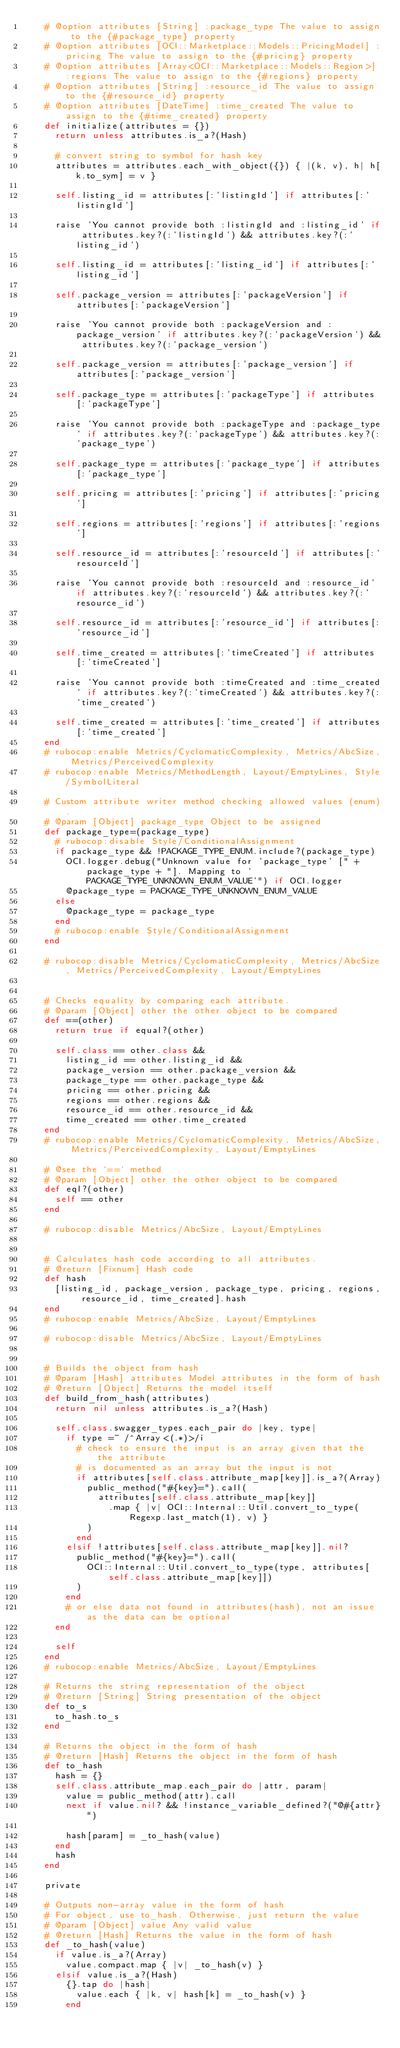Convert code to text. <code><loc_0><loc_0><loc_500><loc_500><_Ruby_>    # @option attributes [String] :package_type The value to assign to the {#package_type} property
    # @option attributes [OCI::Marketplace::Models::PricingModel] :pricing The value to assign to the {#pricing} property
    # @option attributes [Array<OCI::Marketplace::Models::Region>] :regions The value to assign to the {#regions} property
    # @option attributes [String] :resource_id The value to assign to the {#resource_id} property
    # @option attributes [DateTime] :time_created The value to assign to the {#time_created} property
    def initialize(attributes = {})
      return unless attributes.is_a?(Hash)

      # convert string to symbol for hash key
      attributes = attributes.each_with_object({}) { |(k, v), h| h[k.to_sym] = v }

      self.listing_id = attributes[:'listingId'] if attributes[:'listingId']

      raise 'You cannot provide both :listingId and :listing_id' if attributes.key?(:'listingId') && attributes.key?(:'listing_id')

      self.listing_id = attributes[:'listing_id'] if attributes[:'listing_id']

      self.package_version = attributes[:'packageVersion'] if attributes[:'packageVersion']

      raise 'You cannot provide both :packageVersion and :package_version' if attributes.key?(:'packageVersion') && attributes.key?(:'package_version')

      self.package_version = attributes[:'package_version'] if attributes[:'package_version']

      self.package_type = attributes[:'packageType'] if attributes[:'packageType']

      raise 'You cannot provide both :packageType and :package_type' if attributes.key?(:'packageType') && attributes.key?(:'package_type')

      self.package_type = attributes[:'package_type'] if attributes[:'package_type']

      self.pricing = attributes[:'pricing'] if attributes[:'pricing']

      self.regions = attributes[:'regions'] if attributes[:'regions']

      self.resource_id = attributes[:'resourceId'] if attributes[:'resourceId']

      raise 'You cannot provide both :resourceId and :resource_id' if attributes.key?(:'resourceId') && attributes.key?(:'resource_id')

      self.resource_id = attributes[:'resource_id'] if attributes[:'resource_id']

      self.time_created = attributes[:'timeCreated'] if attributes[:'timeCreated']

      raise 'You cannot provide both :timeCreated and :time_created' if attributes.key?(:'timeCreated') && attributes.key?(:'time_created')

      self.time_created = attributes[:'time_created'] if attributes[:'time_created']
    end
    # rubocop:enable Metrics/CyclomaticComplexity, Metrics/AbcSize, Metrics/PerceivedComplexity
    # rubocop:enable Metrics/MethodLength, Layout/EmptyLines, Style/SymbolLiteral

    # Custom attribute writer method checking allowed values (enum).
    # @param [Object] package_type Object to be assigned
    def package_type=(package_type)
      # rubocop:disable Style/ConditionalAssignment
      if package_type && !PACKAGE_TYPE_ENUM.include?(package_type)
        OCI.logger.debug("Unknown value for 'package_type' [" + package_type + "]. Mapping to 'PACKAGE_TYPE_UNKNOWN_ENUM_VALUE'") if OCI.logger
        @package_type = PACKAGE_TYPE_UNKNOWN_ENUM_VALUE
      else
        @package_type = package_type
      end
      # rubocop:enable Style/ConditionalAssignment
    end

    # rubocop:disable Metrics/CyclomaticComplexity, Metrics/AbcSize, Metrics/PerceivedComplexity, Layout/EmptyLines


    # Checks equality by comparing each attribute.
    # @param [Object] other the other object to be compared
    def ==(other)
      return true if equal?(other)

      self.class == other.class &&
        listing_id == other.listing_id &&
        package_version == other.package_version &&
        package_type == other.package_type &&
        pricing == other.pricing &&
        regions == other.regions &&
        resource_id == other.resource_id &&
        time_created == other.time_created
    end
    # rubocop:enable Metrics/CyclomaticComplexity, Metrics/AbcSize, Metrics/PerceivedComplexity, Layout/EmptyLines

    # @see the `==` method
    # @param [Object] other the other object to be compared
    def eql?(other)
      self == other
    end

    # rubocop:disable Metrics/AbcSize, Layout/EmptyLines


    # Calculates hash code according to all attributes.
    # @return [Fixnum] Hash code
    def hash
      [listing_id, package_version, package_type, pricing, regions, resource_id, time_created].hash
    end
    # rubocop:enable Metrics/AbcSize, Layout/EmptyLines

    # rubocop:disable Metrics/AbcSize, Layout/EmptyLines


    # Builds the object from hash
    # @param [Hash] attributes Model attributes in the form of hash
    # @return [Object] Returns the model itself
    def build_from_hash(attributes)
      return nil unless attributes.is_a?(Hash)

      self.class.swagger_types.each_pair do |key, type|
        if type =~ /^Array<(.*)>/i
          # check to ensure the input is an array given that the the attribute
          # is documented as an array but the input is not
          if attributes[self.class.attribute_map[key]].is_a?(Array)
            public_method("#{key}=").call(
              attributes[self.class.attribute_map[key]]
                .map { |v| OCI::Internal::Util.convert_to_type(Regexp.last_match(1), v) }
            )
          end
        elsif !attributes[self.class.attribute_map[key]].nil?
          public_method("#{key}=").call(
            OCI::Internal::Util.convert_to_type(type, attributes[self.class.attribute_map[key]])
          )
        end
        # or else data not found in attributes(hash), not an issue as the data can be optional
      end

      self
    end
    # rubocop:enable Metrics/AbcSize, Layout/EmptyLines

    # Returns the string representation of the object
    # @return [String] String presentation of the object
    def to_s
      to_hash.to_s
    end

    # Returns the object in the form of hash
    # @return [Hash] Returns the object in the form of hash
    def to_hash
      hash = {}
      self.class.attribute_map.each_pair do |attr, param|
        value = public_method(attr).call
        next if value.nil? && !instance_variable_defined?("@#{attr}")

        hash[param] = _to_hash(value)
      end
      hash
    end

    private

    # Outputs non-array value in the form of hash
    # For object, use to_hash. Otherwise, just return the value
    # @param [Object] value Any valid value
    # @return [Hash] Returns the value in the form of hash
    def _to_hash(value)
      if value.is_a?(Array)
        value.compact.map { |v| _to_hash(v) }
      elsif value.is_a?(Hash)
        {}.tap do |hash|
          value.each { |k, v| hash[k] = _to_hash(v) }
        end</code> 